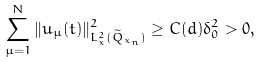<formula> <loc_0><loc_0><loc_500><loc_500>\sum _ { \mu = 1 } ^ { N } \| u _ { \mu } ( t ) \| ^ { 2 } _ { L ^ { 2 } _ { x } ( \widetilde { Q } _ { x _ { n } } ) } \geq C ( d ) \delta ^ { 2 } _ { 0 } > 0 ,</formula> 